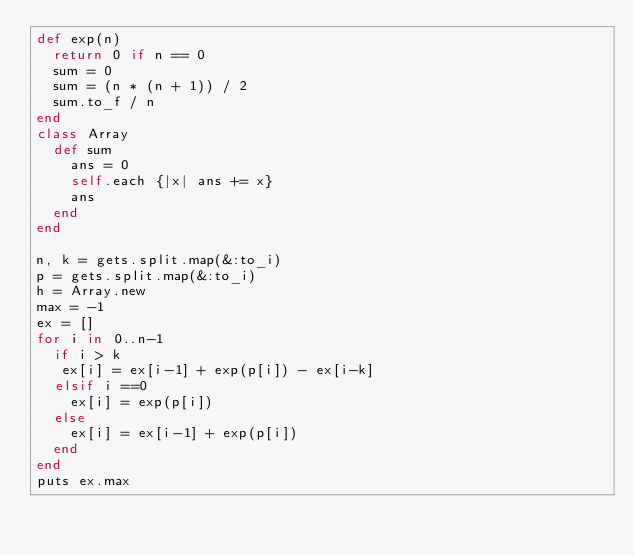<code> <loc_0><loc_0><loc_500><loc_500><_Ruby_>def exp(n)
  return 0 if n == 0
  sum = 0
  sum = (n * (n + 1)) / 2
  sum.to_f / n
end
class Array
  def sum 
    ans = 0
    self.each {|x| ans += x}
    ans
  end
end

n, k = gets.split.map(&:to_i)
p = gets.split.map(&:to_i)
h = Array.new
max = -1
ex = []
for i in 0..n-1
  if i > k
   ex[i] = ex[i-1] + exp(p[i]) - ex[i-k]
  elsif i ==0
    ex[i] = exp(p[i])
  else
    ex[i] = ex[i-1] + exp(p[i])
  end
end
puts ex.max
</code> 